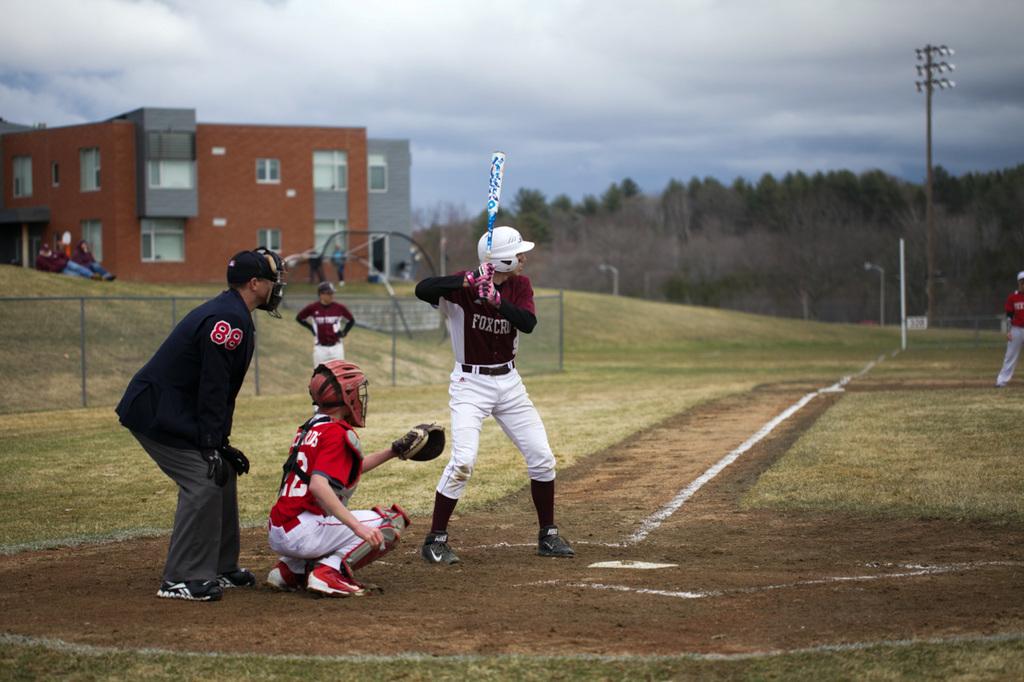What number is the umpire?
Give a very brief answer. 88. What animal name is on the batters jersey?
Give a very brief answer. Fox. 